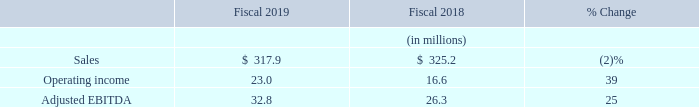Cubic Global Defense
Sales: CGD sales decreased 2% to $317.9 million in 2019 compared to $325.2 million in 2018. The timing of sales recognition was impacted by the adoption of ASC 606. Under ASC 606, a number of our CGD contracts, most significantly in air combat training and ground live training, for which revenue was historically recorded upon delivery of products to the customer, are now accounted for on the percentage-of-completion cost-to-cost method of revenue recognition. For fiscal 2019, sales were lower from air combat training systems, simulation product development contracts, and international services contracts, partially offset by higher sales from ground combat training systems. The average exchange rates between the prevailing currencies in our foreign operations and the U.S. dollar resulted in a decrease in CGD sales of $3.2 million for 2019 compared to 2018.
Amortization of Purchased Intangibles: Amortization of purchased intangibles included in the CGD results amounted to $0.6 million in 2019 and $1.1 million in 2018.
Operating Income: CGD operating income increased by 39% to $23.0 million in 2019 compared to $16.6 million in 2018. For fiscal 2019, operating profits improved primarily due to the results of cost reduction efforts, including headcount reductions designed to optimize our cost position, and reduced R&D expenditures. Operating profits were higher from increased sales of ground combat training system sales but were lower on decreased sales from air combat training systems, simulation product development contracts, and international services contracts. The average exchange rates between the prevailing currency in our foreign operations and the U.S. dollar had no significant impact on CGD operating income between 2018 and 2019.
Adjusted EBITDA: CGD Adjusted EBITDA was $32.8 million in 2019 compared to $26.3 million in 2018. The increase in Adjusted EBITDA was primarily driven by the same factors that drove the increase in operating income described above. Adjusted EBITDA for CGD increased by $3.1 million in 2019 as a result of the adoption of the new revenue recognition standard.
What is the percentage increase in CGD operating income in 2019? 39%. What resulted in the improvement in operating profits? Primarily due to the results of cost reduction efforts, including headcount reductions designed to optimize our cost position, and reduced r&d expenditures, increased sales of ground combat training system sales. For which fiscal year(s) is the amount of amortization of purchased intangibles included in the CGD results recorded? 2019, 2018. In which year was the amount of amortization of purchased intangibles included in the CGD results larger? 0.6<1.1
Answer: 2018. What is the change in the amount of sales from 2018 to 2019?
Answer scale should be: million. 317.9-325.2
Answer: -7.3. What is the average amount of adjusted EBITDA in 2018 and 2019?
Answer scale should be: million. (32.8+26.3)/2
Answer: 29.55. 